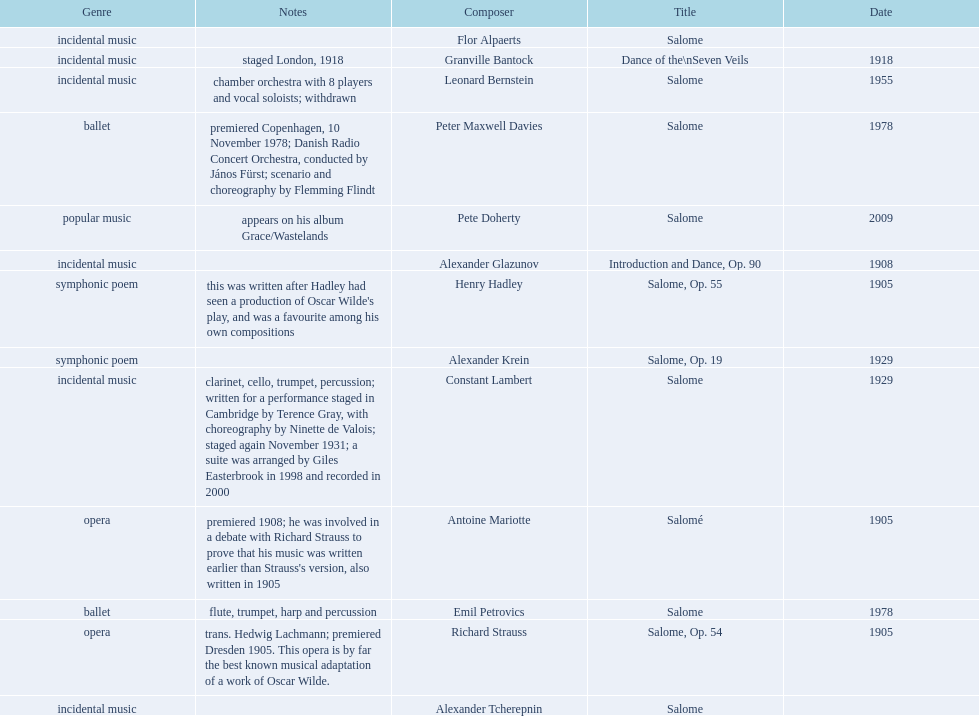Why type of genre was peter maxwell davies' work that was the same as emil petrovics' Ballet. 